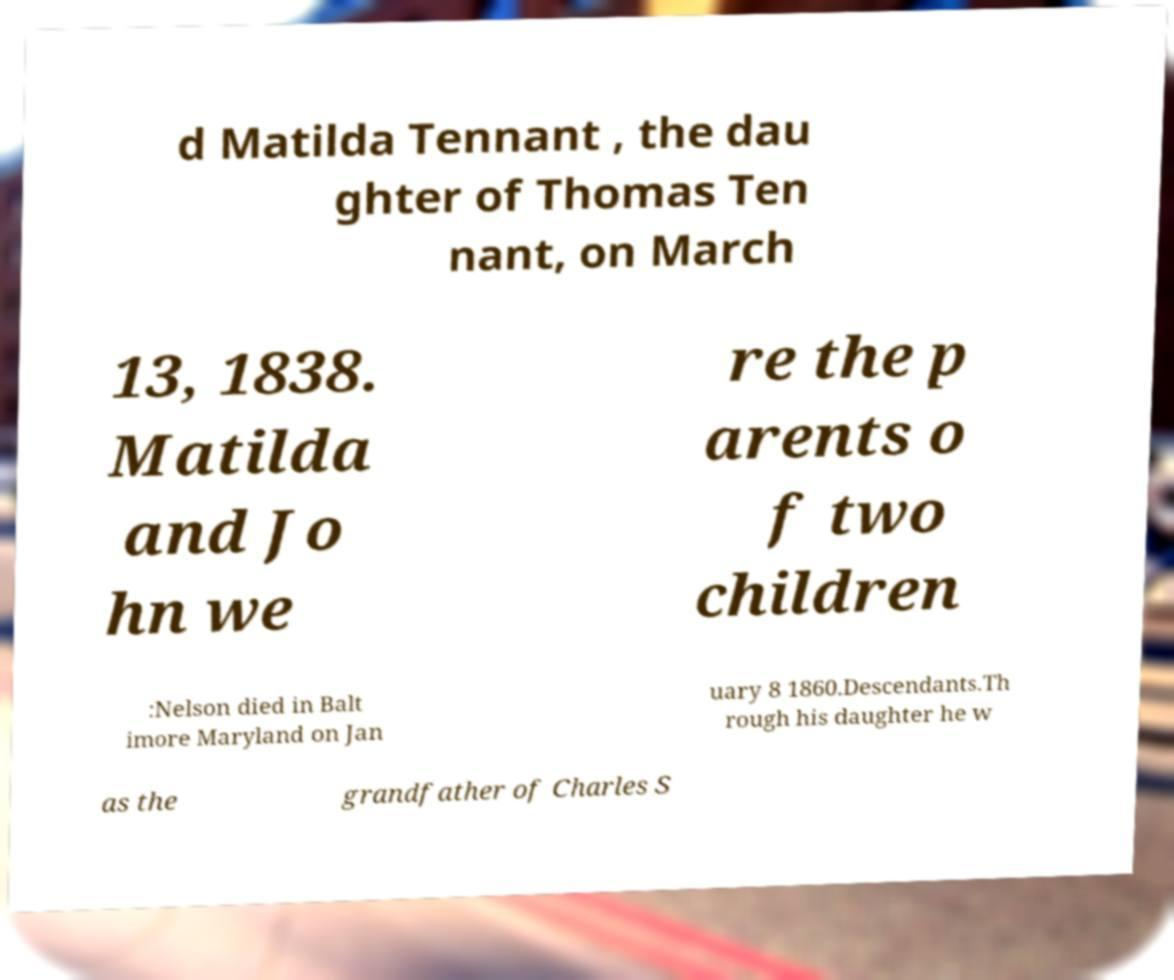There's text embedded in this image that I need extracted. Can you transcribe it verbatim? d Matilda Tennant , the dau ghter of Thomas Ten nant, on March 13, 1838. Matilda and Jo hn we re the p arents o f two children :Nelson died in Balt imore Maryland on Jan uary 8 1860.Descendants.Th rough his daughter he w as the grandfather of Charles S 